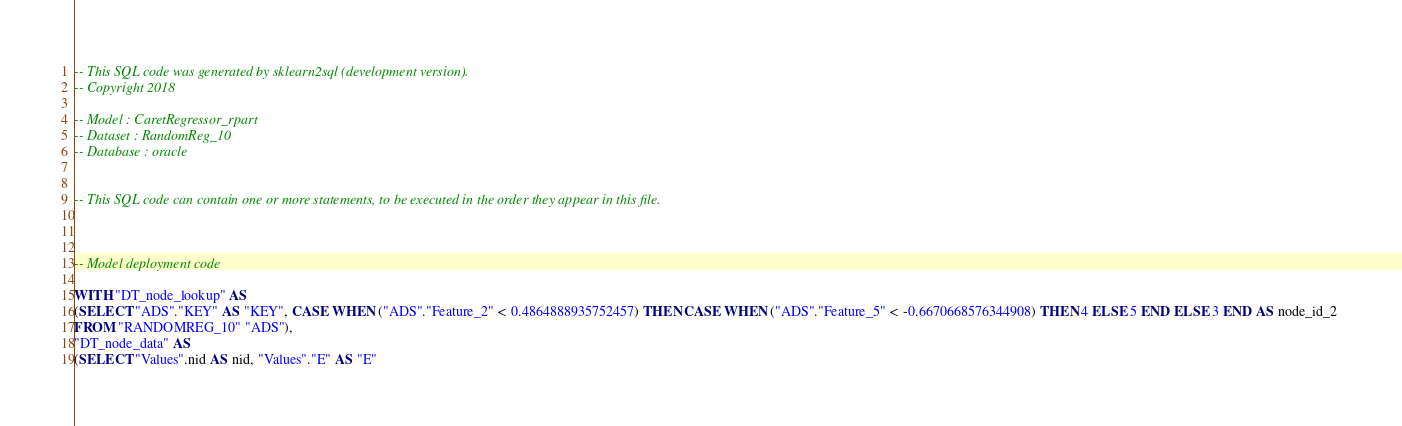Convert code to text. <code><loc_0><loc_0><loc_500><loc_500><_SQL_>-- This SQL code was generated by sklearn2sql (development version).
-- Copyright 2018

-- Model : CaretRegressor_rpart
-- Dataset : RandomReg_10
-- Database : oracle


-- This SQL code can contain one or more statements, to be executed in the order they appear in this file.



-- Model deployment code

WITH "DT_node_lookup" AS 
(SELECT "ADS"."KEY" AS "KEY", CASE WHEN ("ADS"."Feature_2" < 0.4864888935752457) THEN CASE WHEN ("ADS"."Feature_5" < -0.6670668576344908) THEN 4 ELSE 5 END ELSE 3 END AS node_id_2 
FROM "RANDOMREG_10" "ADS"), 
"DT_node_data" AS 
(SELECT "Values".nid AS nid, "Values"."E" AS "E" </code> 